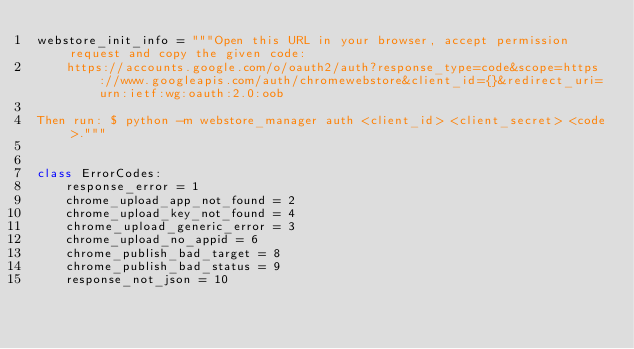Convert code to text. <code><loc_0><loc_0><loc_500><loc_500><_Python_>webstore_init_info = """Open this URL in your browser, accept permission request and copy the given code:
    https://accounts.google.com/o/oauth2/auth?response_type=code&scope=https://www.googleapis.com/auth/chromewebstore&client_id={}&redirect_uri=urn:ietf:wg:oauth:2.0:oob

Then run: $ python -m webstore_manager auth <client_id> <client_secret> <code>."""


class ErrorCodes:
    response_error = 1
    chrome_upload_app_not_found = 2
    chrome_upload_key_not_found = 4
    chrome_upload_generic_error = 3
    chrome_upload_no_appid = 6
    chrome_publish_bad_target = 8
    chrome_publish_bad_status = 9
    response_not_json = 10
</code> 